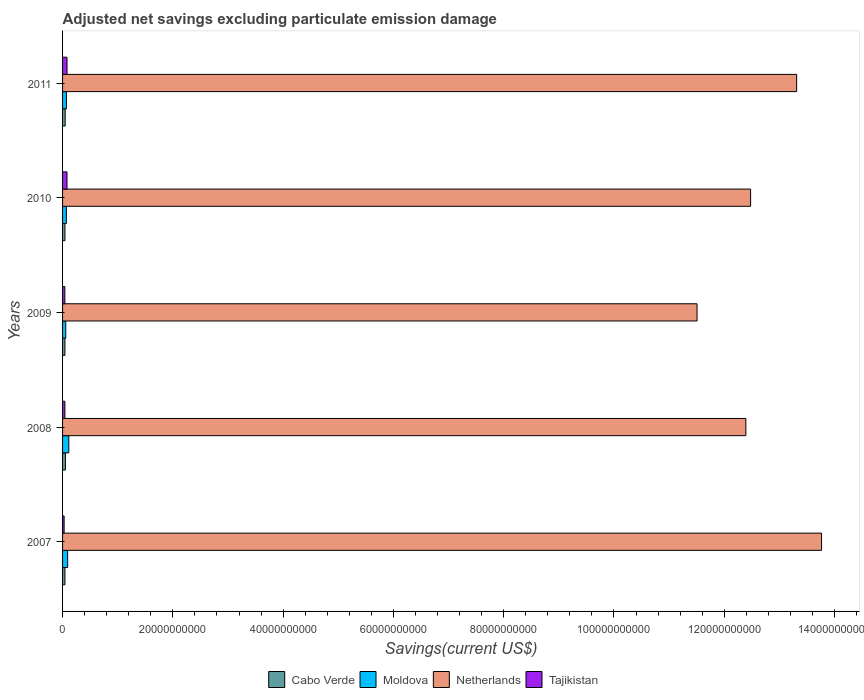How many different coloured bars are there?
Provide a succinct answer. 4. Are the number of bars per tick equal to the number of legend labels?
Keep it short and to the point. Yes. Are the number of bars on each tick of the Y-axis equal?
Give a very brief answer. Yes. How many bars are there on the 1st tick from the top?
Offer a terse response. 4. What is the label of the 1st group of bars from the top?
Your answer should be compact. 2011. In how many cases, is the number of bars for a given year not equal to the number of legend labels?
Offer a very short reply. 0. What is the adjusted net savings in Netherlands in 2008?
Your answer should be very brief. 1.24e+11. Across all years, what is the maximum adjusted net savings in Tajikistan?
Provide a short and direct response. 8.06e+08. Across all years, what is the minimum adjusted net savings in Cabo Verde?
Your answer should be very brief. 4.26e+08. In which year was the adjusted net savings in Cabo Verde minimum?
Your response must be concise. 2009. What is the total adjusted net savings in Moldova in the graph?
Make the answer very short. 4.01e+09. What is the difference between the adjusted net savings in Tajikistan in 2009 and that in 2011?
Your answer should be very brief. -3.93e+08. What is the difference between the adjusted net savings in Cabo Verde in 2010 and the adjusted net savings in Netherlands in 2009?
Make the answer very short. -1.15e+11. What is the average adjusted net savings in Cabo Verde per year?
Provide a succinct answer. 4.56e+08. In the year 2009, what is the difference between the adjusted net savings in Tajikistan and adjusted net savings in Netherlands?
Provide a succinct answer. -1.15e+11. What is the ratio of the adjusted net savings in Cabo Verde in 2007 to that in 2010?
Ensure brevity in your answer.  1. What is the difference between the highest and the second highest adjusted net savings in Tajikistan?
Your response must be concise. 6.09e+04. What is the difference between the highest and the lowest adjusted net savings in Moldova?
Offer a very short reply. 5.53e+08. Is the sum of the adjusted net savings in Tajikistan in 2007 and 2010 greater than the maximum adjusted net savings in Moldova across all years?
Ensure brevity in your answer.  No. What does the 4th bar from the top in 2007 represents?
Provide a succinct answer. Cabo Verde. What does the 1st bar from the bottom in 2009 represents?
Provide a succinct answer. Cabo Verde. How many bars are there?
Give a very brief answer. 20. Are all the bars in the graph horizontal?
Ensure brevity in your answer.  Yes. Are the values on the major ticks of X-axis written in scientific E-notation?
Keep it short and to the point. No. Does the graph contain any zero values?
Your answer should be very brief. No. Does the graph contain grids?
Make the answer very short. No. How many legend labels are there?
Your response must be concise. 4. How are the legend labels stacked?
Your answer should be very brief. Horizontal. What is the title of the graph?
Your response must be concise. Adjusted net savings excluding particulate emission damage. What is the label or title of the X-axis?
Offer a very short reply. Savings(current US$). What is the Savings(current US$) in Cabo Verde in 2007?
Your answer should be very brief. 4.34e+08. What is the Savings(current US$) in Moldova in 2007?
Offer a terse response. 9.20e+08. What is the Savings(current US$) of Netherlands in 2007?
Your response must be concise. 1.38e+11. What is the Savings(current US$) of Tajikistan in 2007?
Offer a terse response. 2.83e+08. What is the Savings(current US$) in Cabo Verde in 2008?
Your answer should be compact. 5.15e+08. What is the Savings(current US$) of Moldova in 2008?
Your answer should be compact. 1.13e+09. What is the Savings(current US$) in Netherlands in 2008?
Provide a succinct answer. 1.24e+11. What is the Savings(current US$) of Tajikistan in 2008?
Provide a succinct answer. 4.25e+08. What is the Savings(current US$) of Cabo Verde in 2009?
Your answer should be compact. 4.26e+08. What is the Savings(current US$) of Moldova in 2009?
Provide a succinct answer. 5.76e+08. What is the Savings(current US$) in Netherlands in 2009?
Your answer should be compact. 1.15e+11. What is the Savings(current US$) of Tajikistan in 2009?
Offer a terse response. 4.13e+08. What is the Savings(current US$) of Cabo Verde in 2010?
Your response must be concise. 4.32e+08. What is the Savings(current US$) of Moldova in 2010?
Give a very brief answer. 6.85e+08. What is the Savings(current US$) in Netherlands in 2010?
Your answer should be compact. 1.25e+11. What is the Savings(current US$) of Tajikistan in 2010?
Your response must be concise. 8.05e+08. What is the Savings(current US$) of Cabo Verde in 2011?
Keep it short and to the point. 4.72e+08. What is the Savings(current US$) in Moldova in 2011?
Provide a short and direct response. 6.98e+08. What is the Savings(current US$) of Netherlands in 2011?
Keep it short and to the point. 1.33e+11. What is the Savings(current US$) in Tajikistan in 2011?
Give a very brief answer. 8.06e+08. Across all years, what is the maximum Savings(current US$) of Cabo Verde?
Give a very brief answer. 5.15e+08. Across all years, what is the maximum Savings(current US$) of Moldova?
Make the answer very short. 1.13e+09. Across all years, what is the maximum Savings(current US$) in Netherlands?
Keep it short and to the point. 1.38e+11. Across all years, what is the maximum Savings(current US$) in Tajikistan?
Provide a short and direct response. 8.06e+08. Across all years, what is the minimum Savings(current US$) in Cabo Verde?
Provide a short and direct response. 4.26e+08. Across all years, what is the minimum Savings(current US$) of Moldova?
Your answer should be compact. 5.76e+08. Across all years, what is the minimum Savings(current US$) of Netherlands?
Give a very brief answer. 1.15e+11. Across all years, what is the minimum Savings(current US$) of Tajikistan?
Make the answer very short. 2.83e+08. What is the total Savings(current US$) of Cabo Verde in the graph?
Ensure brevity in your answer.  2.28e+09. What is the total Savings(current US$) in Moldova in the graph?
Your answer should be compact. 4.01e+09. What is the total Savings(current US$) of Netherlands in the graph?
Your response must be concise. 6.35e+11. What is the total Savings(current US$) in Tajikistan in the graph?
Ensure brevity in your answer.  2.73e+09. What is the difference between the Savings(current US$) in Cabo Verde in 2007 and that in 2008?
Keep it short and to the point. -8.10e+07. What is the difference between the Savings(current US$) in Moldova in 2007 and that in 2008?
Give a very brief answer. -2.10e+08. What is the difference between the Savings(current US$) in Netherlands in 2007 and that in 2008?
Your answer should be very brief. 1.37e+1. What is the difference between the Savings(current US$) of Tajikistan in 2007 and that in 2008?
Offer a very short reply. -1.42e+08. What is the difference between the Savings(current US$) in Cabo Verde in 2007 and that in 2009?
Your answer should be very brief. 7.78e+06. What is the difference between the Savings(current US$) in Moldova in 2007 and that in 2009?
Your answer should be compact. 3.44e+08. What is the difference between the Savings(current US$) in Netherlands in 2007 and that in 2009?
Ensure brevity in your answer.  2.26e+1. What is the difference between the Savings(current US$) in Tajikistan in 2007 and that in 2009?
Give a very brief answer. -1.29e+08. What is the difference between the Savings(current US$) of Cabo Verde in 2007 and that in 2010?
Your response must be concise. 1.15e+06. What is the difference between the Savings(current US$) in Moldova in 2007 and that in 2010?
Make the answer very short. 2.35e+08. What is the difference between the Savings(current US$) of Netherlands in 2007 and that in 2010?
Offer a very short reply. 1.29e+1. What is the difference between the Savings(current US$) in Tajikistan in 2007 and that in 2010?
Make the answer very short. -5.22e+08. What is the difference between the Savings(current US$) in Cabo Verde in 2007 and that in 2011?
Keep it short and to the point. -3.84e+07. What is the difference between the Savings(current US$) in Moldova in 2007 and that in 2011?
Keep it short and to the point. 2.22e+08. What is the difference between the Savings(current US$) in Netherlands in 2007 and that in 2011?
Make the answer very short. 4.51e+09. What is the difference between the Savings(current US$) of Tajikistan in 2007 and that in 2011?
Provide a short and direct response. -5.22e+08. What is the difference between the Savings(current US$) of Cabo Verde in 2008 and that in 2009?
Ensure brevity in your answer.  8.87e+07. What is the difference between the Savings(current US$) in Moldova in 2008 and that in 2009?
Ensure brevity in your answer.  5.53e+08. What is the difference between the Savings(current US$) in Netherlands in 2008 and that in 2009?
Your answer should be very brief. 8.85e+09. What is the difference between the Savings(current US$) of Tajikistan in 2008 and that in 2009?
Your answer should be compact. 1.23e+07. What is the difference between the Savings(current US$) of Cabo Verde in 2008 and that in 2010?
Provide a short and direct response. 8.21e+07. What is the difference between the Savings(current US$) of Moldova in 2008 and that in 2010?
Give a very brief answer. 4.45e+08. What is the difference between the Savings(current US$) of Netherlands in 2008 and that in 2010?
Your answer should be very brief. -8.66e+08. What is the difference between the Savings(current US$) in Tajikistan in 2008 and that in 2010?
Offer a terse response. -3.81e+08. What is the difference between the Savings(current US$) of Cabo Verde in 2008 and that in 2011?
Your response must be concise. 4.26e+07. What is the difference between the Savings(current US$) in Moldova in 2008 and that in 2011?
Your answer should be compact. 4.32e+08. What is the difference between the Savings(current US$) in Netherlands in 2008 and that in 2011?
Ensure brevity in your answer.  -9.21e+09. What is the difference between the Savings(current US$) of Tajikistan in 2008 and that in 2011?
Your answer should be very brief. -3.81e+08. What is the difference between the Savings(current US$) of Cabo Verde in 2009 and that in 2010?
Provide a short and direct response. -6.63e+06. What is the difference between the Savings(current US$) of Moldova in 2009 and that in 2010?
Provide a succinct answer. -1.08e+08. What is the difference between the Savings(current US$) in Netherlands in 2009 and that in 2010?
Your answer should be very brief. -9.71e+09. What is the difference between the Savings(current US$) in Tajikistan in 2009 and that in 2010?
Keep it short and to the point. -3.93e+08. What is the difference between the Savings(current US$) of Cabo Verde in 2009 and that in 2011?
Your response must be concise. -4.61e+07. What is the difference between the Savings(current US$) in Moldova in 2009 and that in 2011?
Offer a terse response. -1.22e+08. What is the difference between the Savings(current US$) of Netherlands in 2009 and that in 2011?
Your answer should be compact. -1.81e+1. What is the difference between the Savings(current US$) of Tajikistan in 2009 and that in 2011?
Provide a short and direct response. -3.93e+08. What is the difference between the Savings(current US$) of Cabo Verde in 2010 and that in 2011?
Provide a succinct answer. -3.95e+07. What is the difference between the Savings(current US$) in Moldova in 2010 and that in 2011?
Provide a succinct answer. -1.33e+07. What is the difference between the Savings(current US$) in Netherlands in 2010 and that in 2011?
Make the answer very short. -8.35e+09. What is the difference between the Savings(current US$) in Tajikistan in 2010 and that in 2011?
Keep it short and to the point. -6.09e+04. What is the difference between the Savings(current US$) in Cabo Verde in 2007 and the Savings(current US$) in Moldova in 2008?
Make the answer very short. -6.96e+08. What is the difference between the Savings(current US$) in Cabo Verde in 2007 and the Savings(current US$) in Netherlands in 2008?
Your answer should be very brief. -1.23e+11. What is the difference between the Savings(current US$) of Cabo Verde in 2007 and the Savings(current US$) of Tajikistan in 2008?
Provide a succinct answer. 8.72e+06. What is the difference between the Savings(current US$) in Moldova in 2007 and the Savings(current US$) in Netherlands in 2008?
Make the answer very short. -1.23e+11. What is the difference between the Savings(current US$) in Moldova in 2007 and the Savings(current US$) in Tajikistan in 2008?
Keep it short and to the point. 4.95e+08. What is the difference between the Savings(current US$) in Netherlands in 2007 and the Savings(current US$) in Tajikistan in 2008?
Your answer should be very brief. 1.37e+11. What is the difference between the Savings(current US$) in Cabo Verde in 2007 and the Savings(current US$) in Moldova in 2009?
Offer a very short reply. -1.43e+08. What is the difference between the Savings(current US$) of Cabo Verde in 2007 and the Savings(current US$) of Netherlands in 2009?
Offer a very short reply. -1.15e+11. What is the difference between the Savings(current US$) of Cabo Verde in 2007 and the Savings(current US$) of Tajikistan in 2009?
Provide a succinct answer. 2.10e+07. What is the difference between the Savings(current US$) in Moldova in 2007 and the Savings(current US$) in Netherlands in 2009?
Keep it short and to the point. -1.14e+11. What is the difference between the Savings(current US$) in Moldova in 2007 and the Savings(current US$) in Tajikistan in 2009?
Your response must be concise. 5.07e+08. What is the difference between the Savings(current US$) in Netherlands in 2007 and the Savings(current US$) in Tajikistan in 2009?
Make the answer very short. 1.37e+11. What is the difference between the Savings(current US$) of Cabo Verde in 2007 and the Savings(current US$) of Moldova in 2010?
Make the answer very short. -2.51e+08. What is the difference between the Savings(current US$) in Cabo Verde in 2007 and the Savings(current US$) in Netherlands in 2010?
Your response must be concise. -1.24e+11. What is the difference between the Savings(current US$) in Cabo Verde in 2007 and the Savings(current US$) in Tajikistan in 2010?
Give a very brief answer. -3.72e+08. What is the difference between the Savings(current US$) of Moldova in 2007 and the Savings(current US$) of Netherlands in 2010?
Provide a short and direct response. -1.24e+11. What is the difference between the Savings(current US$) of Moldova in 2007 and the Savings(current US$) of Tajikistan in 2010?
Offer a terse response. 1.15e+08. What is the difference between the Savings(current US$) in Netherlands in 2007 and the Savings(current US$) in Tajikistan in 2010?
Offer a very short reply. 1.37e+11. What is the difference between the Savings(current US$) in Cabo Verde in 2007 and the Savings(current US$) in Moldova in 2011?
Your response must be concise. -2.65e+08. What is the difference between the Savings(current US$) in Cabo Verde in 2007 and the Savings(current US$) in Netherlands in 2011?
Your answer should be very brief. -1.33e+11. What is the difference between the Savings(current US$) of Cabo Verde in 2007 and the Savings(current US$) of Tajikistan in 2011?
Make the answer very short. -3.72e+08. What is the difference between the Savings(current US$) in Moldova in 2007 and the Savings(current US$) in Netherlands in 2011?
Your response must be concise. -1.32e+11. What is the difference between the Savings(current US$) of Moldova in 2007 and the Savings(current US$) of Tajikistan in 2011?
Provide a short and direct response. 1.15e+08. What is the difference between the Savings(current US$) in Netherlands in 2007 and the Savings(current US$) in Tajikistan in 2011?
Provide a short and direct response. 1.37e+11. What is the difference between the Savings(current US$) in Cabo Verde in 2008 and the Savings(current US$) in Moldova in 2009?
Keep it short and to the point. -6.18e+07. What is the difference between the Savings(current US$) in Cabo Verde in 2008 and the Savings(current US$) in Netherlands in 2009?
Offer a very short reply. -1.15e+11. What is the difference between the Savings(current US$) of Cabo Verde in 2008 and the Savings(current US$) of Tajikistan in 2009?
Ensure brevity in your answer.  1.02e+08. What is the difference between the Savings(current US$) of Moldova in 2008 and the Savings(current US$) of Netherlands in 2009?
Give a very brief answer. -1.14e+11. What is the difference between the Savings(current US$) of Moldova in 2008 and the Savings(current US$) of Tajikistan in 2009?
Your answer should be very brief. 7.17e+08. What is the difference between the Savings(current US$) of Netherlands in 2008 and the Savings(current US$) of Tajikistan in 2009?
Provide a succinct answer. 1.23e+11. What is the difference between the Savings(current US$) in Cabo Verde in 2008 and the Savings(current US$) in Moldova in 2010?
Your answer should be very brief. -1.70e+08. What is the difference between the Savings(current US$) of Cabo Verde in 2008 and the Savings(current US$) of Netherlands in 2010?
Your response must be concise. -1.24e+11. What is the difference between the Savings(current US$) in Cabo Verde in 2008 and the Savings(current US$) in Tajikistan in 2010?
Your response must be concise. -2.91e+08. What is the difference between the Savings(current US$) of Moldova in 2008 and the Savings(current US$) of Netherlands in 2010?
Your answer should be compact. -1.24e+11. What is the difference between the Savings(current US$) of Moldova in 2008 and the Savings(current US$) of Tajikistan in 2010?
Your answer should be compact. 3.24e+08. What is the difference between the Savings(current US$) of Netherlands in 2008 and the Savings(current US$) of Tajikistan in 2010?
Your answer should be compact. 1.23e+11. What is the difference between the Savings(current US$) of Cabo Verde in 2008 and the Savings(current US$) of Moldova in 2011?
Your response must be concise. -1.84e+08. What is the difference between the Savings(current US$) of Cabo Verde in 2008 and the Savings(current US$) of Netherlands in 2011?
Offer a terse response. -1.33e+11. What is the difference between the Savings(current US$) of Cabo Verde in 2008 and the Savings(current US$) of Tajikistan in 2011?
Ensure brevity in your answer.  -2.91e+08. What is the difference between the Savings(current US$) of Moldova in 2008 and the Savings(current US$) of Netherlands in 2011?
Keep it short and to the point. -1.32e+11. What is the difference between the Savings(current US$) of Moldova in 2008 and the Savings(current US$) of Tajikistan in 2011?
Provide a succinct answer. 3.24e+08. What is the difference between the Savings(current US$) of Netherlands in 2008 and the Savings(current US$) of Tajikistan in 2011?
Provide a succinct answer. 1.23e+11. What is the difference between the Savings(current US$) in Cabo Verde in 2009 and the Savings(current US$) in Moldova in 2010?
Provide a succinct answer. -2.59e+08. What is the difference between the Savings(current US$) of Cabo Verde in 2009 and the Savings(current US$) of Netherlands in 2010?
Provide a short and direct response. -1.24e+11. What is the difference between the Savings(current US$) in Cabo Verde in 2009 and the Savings(current US$) in Tajikistan in 2010?
Offer a terse response. -3.80e+08. What is the difference between the Savings(current US$) in Moldova in 2009 and the Savings(current US$) in Netherlands in 2010?
Your answer should be compact. -1.24e+11. What is the difference between the Savings(current US$) in Moldova in 2009 and the Savings(current US$) in Tajikistan in 2010?
Ensure brevity in your answer.  -2.29e+08. What is the difference between the Savings(current US$) of Netherlands in 2009 and the Savings(current US$) of Tajikistan in 2010?
Ensure brevity in your answer.  1.14e+11. What is the difference between the Savings(current US$) of Cabo Verde in 2009 and the Savings(current US$) of Moldova in 2011?
Offer a very short reply. -2.72e+08. What is the difference between the Savings(current US$) of Cabo Verde in 2009 and the Savings(current US$) of Netherlands in 2011?
Provide a succinct answer. -1.33e+11. What is the difference between the Savings(current US$) of Cabo Verde in 2009 and the Savings(current US$) of Tajikistan in 2011?
Make the answer very short. -3.80e+08. What is the difference between the Savings(current US$) in Moldova in 2009 and the Savings(current US$) in Netherlands in 2011?
Provide a short and direct response. -1.33e+11. What is the difference between the Savings(current US$) in Moldova in 2009 and the Savings(current US$) in Tajikistan in 2011?
Ensure brevity in your answer.  -2.29e+08. What is the difference between the Savings(current US$) of Netherlands in 2009 and the Savings(current US$) of Tajikistan in 2011?
Your response must be concise. 1.14e+11. What is the difference between the Savings(current US$) in Cabo Verde in 2010 and the Savings(current US$) in Moldova in 2011?
Give a very brief answer. -2.66e+08. What is the difference between the Savings(current US$) of Cabo Verde in 2010 and the Savings(current US$) of Netherlands in 2011?
Provide a short and direct response. -1.33e+11. What is the difference between the Savings(current US$) in Cabo Verde in 2010 and the Savings(current US$) in Tajikistan in 2011?
Your response must be concise. -3.73e+08. What is the difference between the Savings(current US$) of Moldova in 2010 and the Savings(current US$) of Netherlands in 2011?
Give a very brief answer. -1.32e+11. What is the difference between the Savings(current US$) in Moldova in 2010 and the Savings(current US$) in Tajikistan in 2011?
Provide a succinct answer. -1.21e+08. What is the difference between the Savings(current US$) of Netherlands in 2010 and the Savings(current US$) of Tajikistan in 2011?
Your answer should be very brief. 1.24e+11. What is the average Savings(current US$) in Cabo Verde per year?
Your answer should be very brief. 4.56e+08. What is the average Savings(current US$) in Moldova per year?
Keep it short and to the point. 8.02e+08. What is the average Savings(current US$) in Netherlands per year?
Make the answer very short. 1.27e+11. What is the average Savings(current US$) of Tajikistan per year?
Make the answer very short. 5.46e+08. In the year 2007, what is the difference between the Savings(current US$) of Cabo Verde and Savings(current US$) of Moldova?
Offer a terse response. -4.87e+08. In the year 2007, what is the difference between the Savings(current US$) in Cabo Verde and Savings(current US$) in Netherlands?
Keep it short and to the point. -1.37e+11. In the year 2007, what is the difference between the Savings(current US$) in Cabo Verde and Savings(current US$) in Tajikistan?
Your response must be concise. 1.50e+08. In the year 2007, what is the difference between the Savings(current US$) of Moldova and Savings(current US$) of Netherlands?
Provide a short and direct response. -1.37e+11. In the year 2007, what is the difference between the Savings(current US$) in Moldova and Savings(current US$) in Tajikistan?
Your answer should be very brief. 6.37e+08. In the year 2007, what is the difference between the Savings(current US$) of Netherlands and Savings(current US$) of Tajikistan?
Keep it short and to the point. 1.37e+11. In the year 2008, what is the difference between the Savings(current US$) in Cabo Verde and Savings(current US$) in Moldova?
Provide a short and direct response. -6.15e+08. In the year 2008, what is the difference between the Savings(current US$) in Cabo Verde and Savings(current US$) in Netherlands?
Offer a very short reply. -1.23e+11. In the year 2008, what is the difference between the Savings(current US$) of Cabo Verde and Savings(current US$) of Tajikistan?
Keep it short and to the point. 8.97e+07. In the year 2008, what is the difference between the Savings(current US$) in Moldova and Savings(current US$) in Netherlands?
Your answer should be compact. -1.23e+11. In the year 2008, what is the difference between the Savings(current US$) of Moldova and Savings(current US$) of Tajikistan?
Your answer should be compact. 7.05e+08. In the year 2008, what is the difference between the Savings(current US$) in Netherlands and Savings(current US$) in Tajikistan?
Make the answer very short. 1.23e+11. In the year 2009, what is the difference between the Savings(current US$) of Cabo Verde and Savings(current US$) of Moldova?
Provide a succinct answer. -1.51e+08. In the year 2009, what is the difference between the Savings(current US$) in Cabo Verde and Savings(current US$) in Netherlands?
Make the answer very short. -1.15e+11. In the year 2009, what is the difference between the Savings(current US$) of Cabo Verde and Savings(current US$) of Tajikistan?
Your response must be concise. 1.32e+07. In the year 2009, what is the difference between the Savings(current US$) of Moldova and Savings(current US$) of Netherlands?
Offer a terse response. -1.14e+11. In the year 2009, what is the difference between the Savings(current US$) of Moldova and Savings(current US$) of Tajikistan?
Your response must be concise. 1.64e+08. In the year 2009, what is the difference between the Savings(current US$) of Netherlands and Savings(current US$) of Tajikistan?
Your answer should be very brief. 1.15e+11. In the year 2010, what is the difference between the Savings(current US$) of Cabo Verde and Savings(current US$) of Moldova?
Ensure brevity in your answer.  -2.52e+08. In the year 2010, what is the difference between the Savings(current US$) in Cabo Verde and Savings(current US$) in Netherlands?
Give a very brief answer. -1.24e+11. In the year 2010, what is the difference between the Savings(current US$) in Cabo Verde and Savings(current US$) in Tajikistan?
Provide a succinct answer. -3.73e+08. In the year 2010, what is the difference between the Savings(current US$) of Moldova and Savings(current US$) of Netherlands?
Your response must be concise. -1.24e+11. In the year 2010, what is the difference between the Savings(current US$) of Moldova and Savings(current US$) of Tajikistan?
Offer a terse response. -1.21e+08. In the year 2010, what is the difference between the Savings(current US$) of Netherlands and Savings(current US$) of Tajikistan?
Offer a very short reply. 1.24e+11. In the year 2011, what is the difference between the Savings(current US$) of Cabo Verde and Savings(current US$) of Moldova?
Your response must be concise. -2.26e+08. In the year 2011, what is the difference between the Savings(current US$) in Cabo Verde and Savings(current US$) in Netherlands?
Provide a succinct answer. -1.33e+11. In the year 2011, what is the difference between the Savings(current US$) of Cabo Verde and Savings(current US$) of Tajikistan?
Ensure brevity in your answer.  -3.34e+08. In the year 2011, what is the difference between the Savings(current US$) of Moldova and Savings(current US$) of Netherlands?
Provide a succinct answer. -1.32e+11. In the year 2011, what is the difference between the Savings(current US$) in Moldova and Savings(current US$) in Tajikistan?
Make the answer very short. -1.07e+08. In the year 2011, what is the difference between the Savings(current US$) in Netherlands and Savings(current US$) in Tajikistan?
Your answer should be very brief. 1.32e+11. What is the ratio of the Savings(current US$) of Cabo Verde in 2007 to that in 2008?
Your answer should be compact. 0.84. What is the ratio of the Savings(current US$) in Moldova in 2007 to that in 2008?
Offer a very short reply. 0.81. What is the ratio of the Savings(current US$) of Netherlands in 2007 to that in 2008?
Keep it short and to the point. 1.11. What is the ratio of the Savings(current US$) in Tajikistan in 2007 to that in 2008?
Offer a terse response. 0.67. What is the ratio of the Savings(current US$) in Cabo Verde in 2007 to that in 2009?
Ensure brevity in your answer.  1.02. What is the ratio of the Savings(current US$) of Moldova in 2007 to that in 2009?
Provide a succinct answer. 1.6. What is the ratio of the Savings(current US$) of Netherlands in 2007 to that in 2009?
Your answer should be compact. 1.2. What is the ratio of the Savings(current US$) of Tajikistan in 2007 to that in 2009?
Provide a short and direct response. 0.69. What is the ratio of the Savings(current US$) in Cabo Verde in 2007 to that in 2010?
Offer a terse response. 1. What is the ratio of the Savings(current US$) of Moldova in 2007 to that in 2010?
Your answer should be compact. 1.34. What is the ratio of the Savings(current US$) in Netherlands in 2007 to that in 2010?
Provide a short and direct response. 1.1. What is the ratio of the Savings(current US$) in Tajikistan in 2007 to that in 2010?
Ensure brevity in your answer.  0.35. What is the ratio of the Savings(current US$) of Cabo Verde in 2007 to that in 2011?
Offer a very short reply. 0.92. What is the ratio of the Savings(current US$) of Moldova in 2007 to that in 2011?
Give a very brief answer. 1.32. What is the ratio of the Savings(current US$) in Netherlands in 2007 to that in 2011?
Make the answer very short. 1.03. What is the ratio of the Savings(current US$) in Tajikistan in 2007 to that in 2011?
Ensure brevity in your answer.  0.35. What is the ratio of the Savings(current US$) in Cabo Verde in 2008 to that in 2009?
Your answer should be very brief. 1.21. What is the ratio of the Savings(current US$) in Moldova in 2008 to that in 2009?
Provide a succinct answer. 1.96. What is the ratio of the Savings(current US$) in Tajikistan in 2008 to that in 2009?
Your answer should be very brief. 1.03. What is the ratio of the Savings(current US$) of Cabo Verde in 2008 to that in 2010?
Provide a succinct answer. 1.19. What is the ratio of the Savings(current US$) of Moldova in 2008 to that in 2010?
Make the answer very short. 1.65. What is the ratio of the Savings(current US$) in Netherlands in 2008 to that in 2010?
Your response must be concise. 0.99. What is the ratio of the Savings(current US$) of Tajikistan in 2008 to that in 2010?
Offer a very short reply. 0.53. What is the ratio of the Savings(current US$) in Cabo Verde in 2008 to that in 2011?
Give a very brief answer. 1.09. What is the ratio of the Savings(current US$) of Moldova in 2008 to that in 2011?
Offer a terse response. 1.62. What is the ratio of the Savings(current US$) in Netherlands in 2008 to that in 2011?
Your answer should be compact. 0.93. What is the ratio of the Savings(current US$) in Tajikistan in 2008 to that in 2011?
Make the answer very short. 0.53. What is the ratio of the Savings(current US$) in Cabo Verde in 2009 to that in 2010?
Provide a succinct answer. 0.98. What is the ratio of the Savings(current US$) of Moldova in 2009 to that in 2010?
Keep it short and to the point. 0.84. What is the ratio of the Savings(current US$) in Netherlands in 2009 to that in 2010?
Give a very brief answer. 0.92. What is the ratio of the Savings(current US$) in Tajikistan in 2009 to that in 2010?
Provide a succinct answer. 0.51. What is the ratio of the Savings(current US$) of Cabo Verde in 2009 to that in 2011?
Make the answer very short. 0.9. What is the ratio of the Savings(current US$) of Moldova in 2009 to that in 2011?
Your response must be concise. 0.83. What is the ratio of the Savings(current US$) in Netherlands in 2009 to that in 2011?
Your answer should be very brief. 0.86. What is the ratio of the Savings(current US$) in Tajikistan in 2009 to that in 2011?
Offer a terse response. 0.51. What is the ratio of the Savings(current US$) of Cabo Verde in 2010 to that in 2011?
Your answer should be very brief. 0.92. What is the ratio of the Savings(current US$) of Moldova in 2010 to that in 2011?
Keep it short and to the point. 0.98. What is the ratio of the Savings(current US$) of Netherlands in 2010 to that in 2011?
Give a very brief answer. 0.94. What is the difference between the highest and the second highest Savings(current US$) of Cabo Verde?
Provide a short and direct response. 4.26e+07. What is the difference between the highest and the second highest Savings(current US$) of Moldova?
Provide a short and direct response. 2.10e+08. What is the difference between the highest and the second highest Savings(current US$) of Netherlands?
Provide a succinct answer. 4.51e+09. What is the difference between the highest and the second highest Savings(current US$) of Tajikistan?
Keep it short and to the point. 6.09e+04. What is the difference between the highest and the lowest Savings(current US$) of Cabo Verde?
Keep it short and to the point. 8.87e+07. What is the difference between the highest and the lowest Savings(current US$) in Moldova?
Give a very brief answer. 5.53e+08. What is the difference between the highest and the lowest Savings(current US$) in Netherlands?
Ensure brevity in your answer.  2.26e+1. What is the difference between the highest and the lowest Savings(current US$) in Tajikistan?
Your answer should be compact. 5.22e+08. 